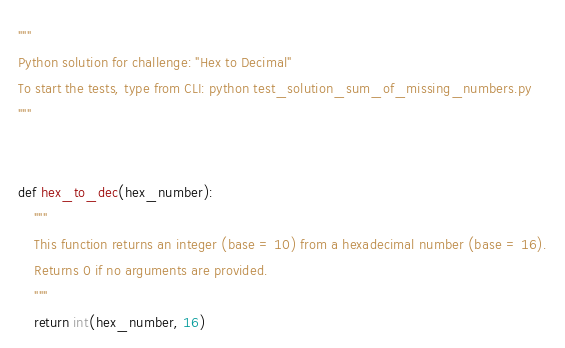Convert code to text. <code><loc_0><loc_0><loc_500><loc_500><_Python_>"""
Python solution for challenge: "Hex to Decimal"
To start the tests, type from CLI: python test_solution_sum_of_missing_numbers.py
"""


def hex_to_dec(hex_number):
    """
    This function returns an integer (base = 10) from a hexadecimal number (base = 16).
    Returns 0 if no arguments are provided.
    """
    return int(hex_number, 16)
</code> 